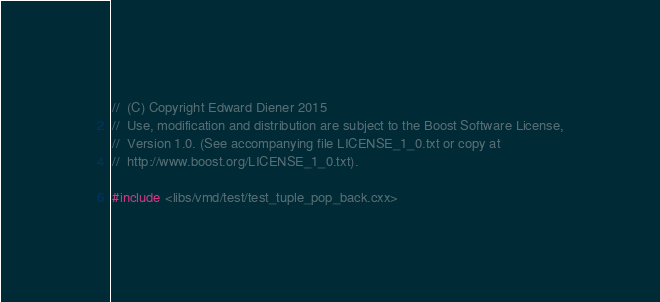Convert code to text. <code><loc_0><loc_0><loc_500><loc_500><_C++_>
//  (C) Copyright Edward Diener 2015
//  Use, modification and distribution are subject to the Boost Software License,
//  Version 1.0. (See accompanying file LICENSE_1_0.txt or copy at
//  http://www.boost.org/LICENSE_1_0.txt).

#include <libs/vmd/test/test_tuple_pop_back.cxx>
</code> 